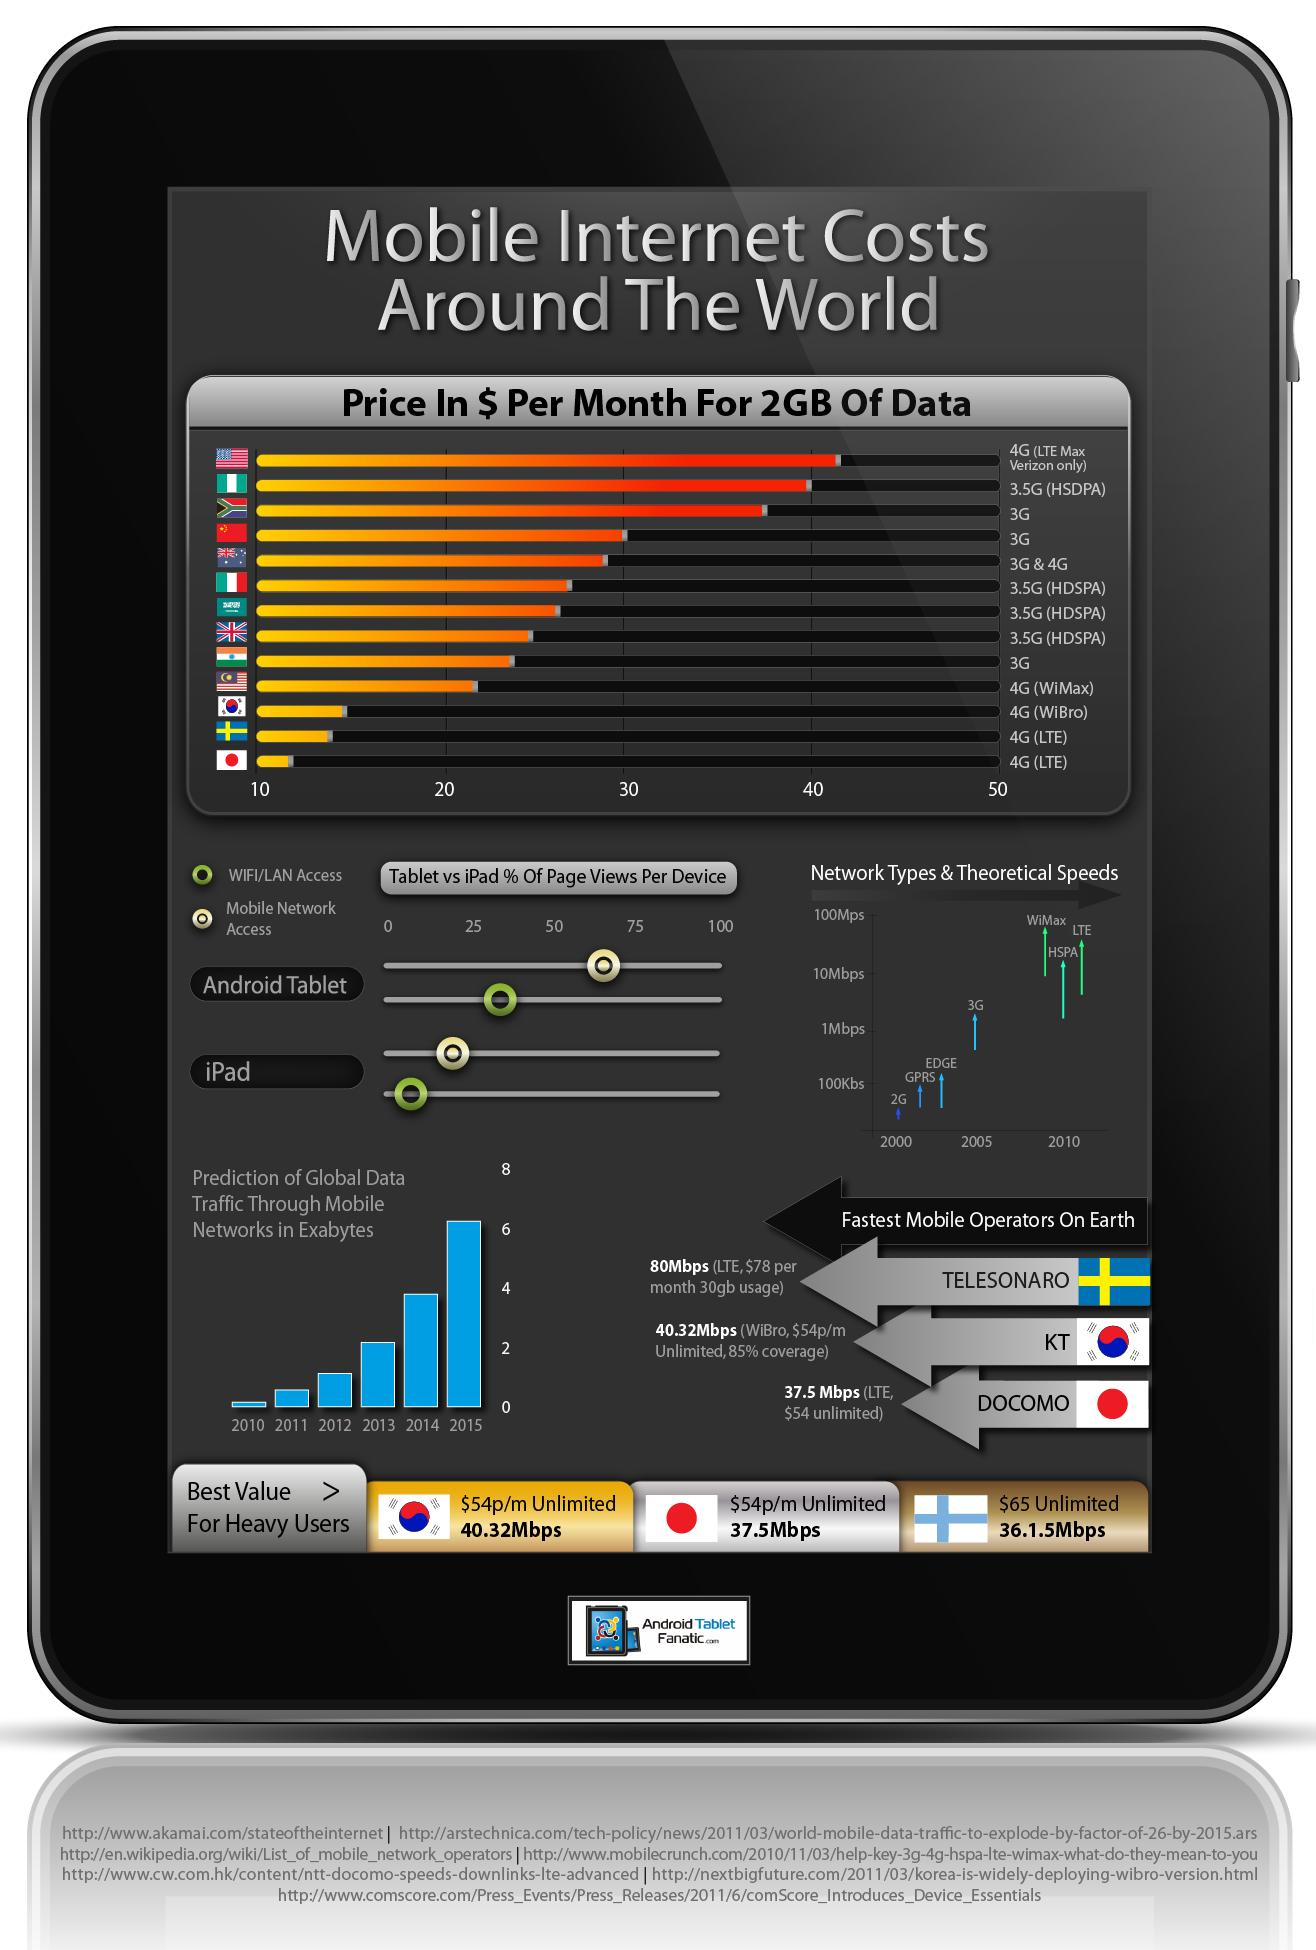Mention a couple of crucial points in this snapshot. The fastest mobile operators are China, Japan, India, and America. Japan has the third fastest mobile operators. According to the information provided, India is the best country to have access to 3G internet services. In 2010, HSPA (High-Speed Packet Access) was the third fastest mobile network type in terms of speed. In 2012, the global data traffic was approximately 0.7 exabytes. DOCOMO, the mobile operator from Japan, ranks third among the fastest mobile operators on earth. 